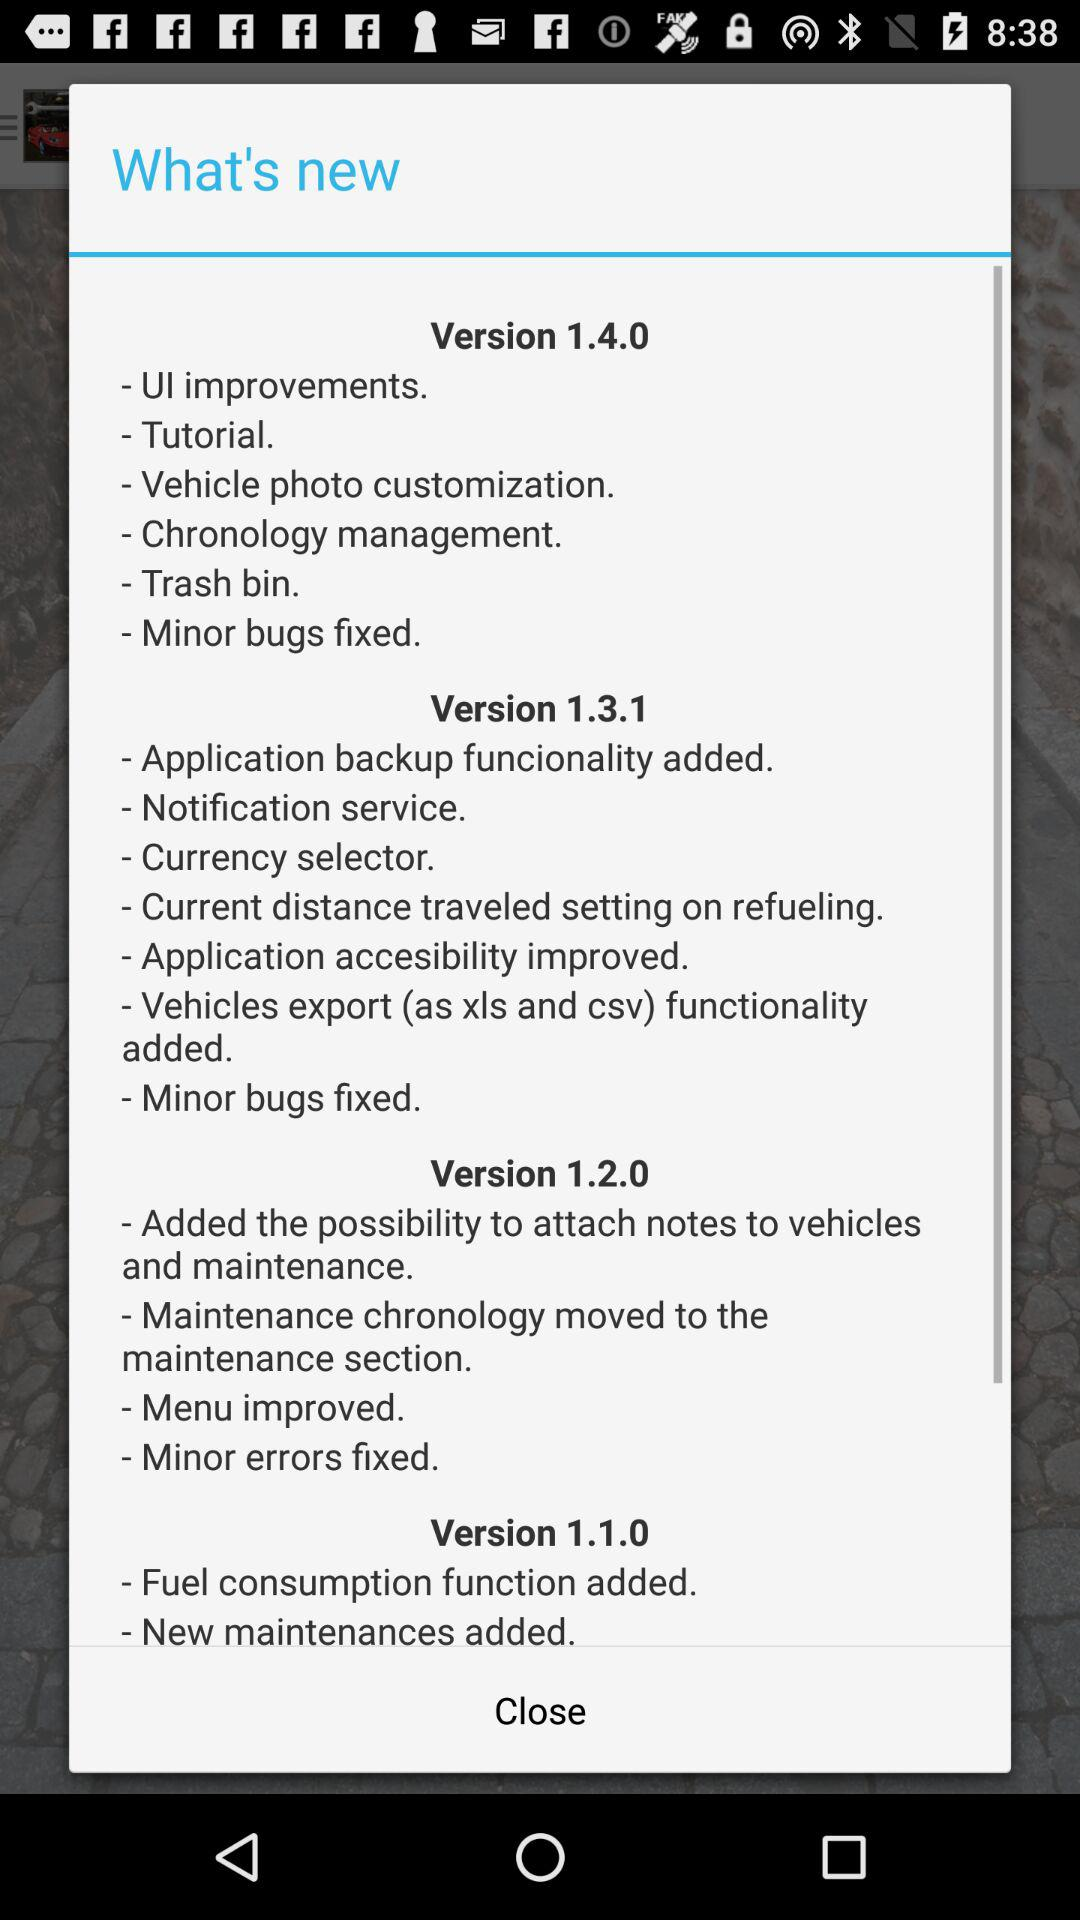How many new features were added to the app in the 1.4.0 version?
Answer the question using a single word or phrase. 6 